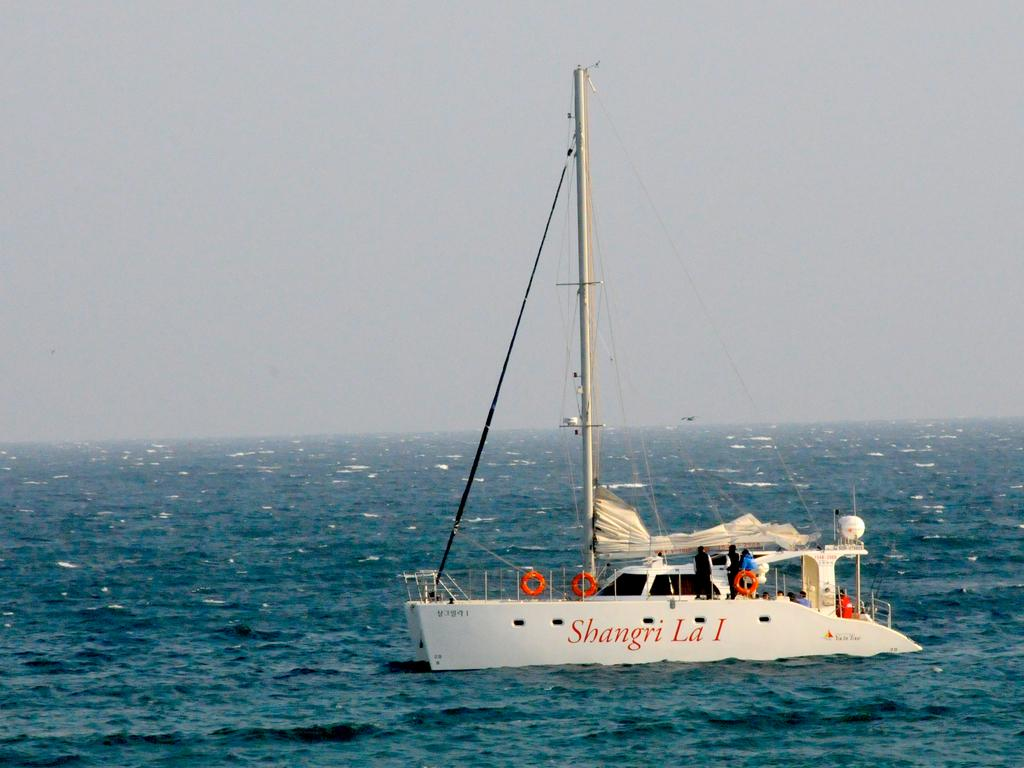What is the main subject of the picture? The main subject of the picture is a ship. What color is the ship? The ship is white in color. Are there any people on the ship? Yes, there are people standing on the ship. Where is the ship located? The ship is on the water. What type of weather can be seen in the image? The provided facts do not mention any weather conditions, so it cannot be determined from the image. Are there any giants visible on the ship? There are no giants present in the image; only people are visible on the ship. 